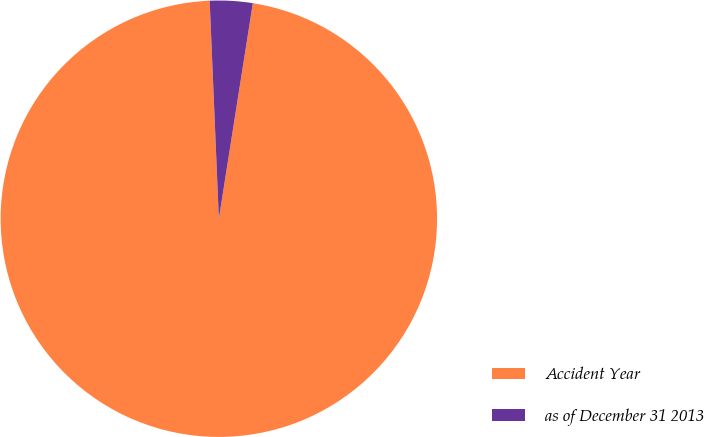<chart> <loc_0><loc_0><loc_500><loc_500><pie_chart><fcel>Accident Year<fcel>as of December 31 2013<nl><fcel>96.84%<fcel>3.16%<nl></chart> 